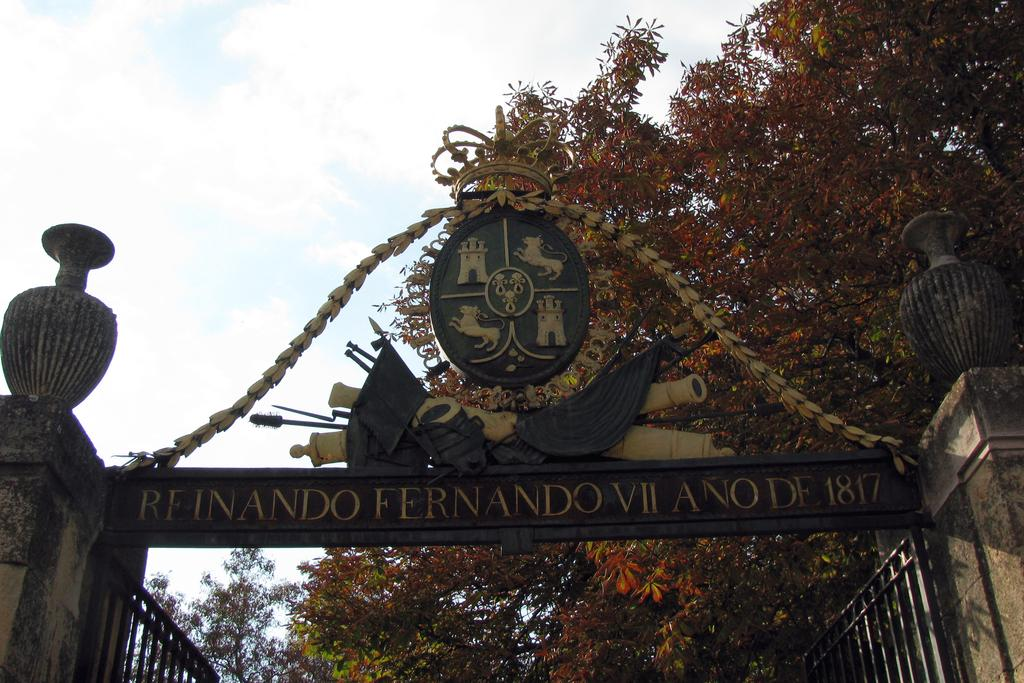<image>
Offer a succinct explanation of the picture presented. Wording above an open gate says REINANDO on it 